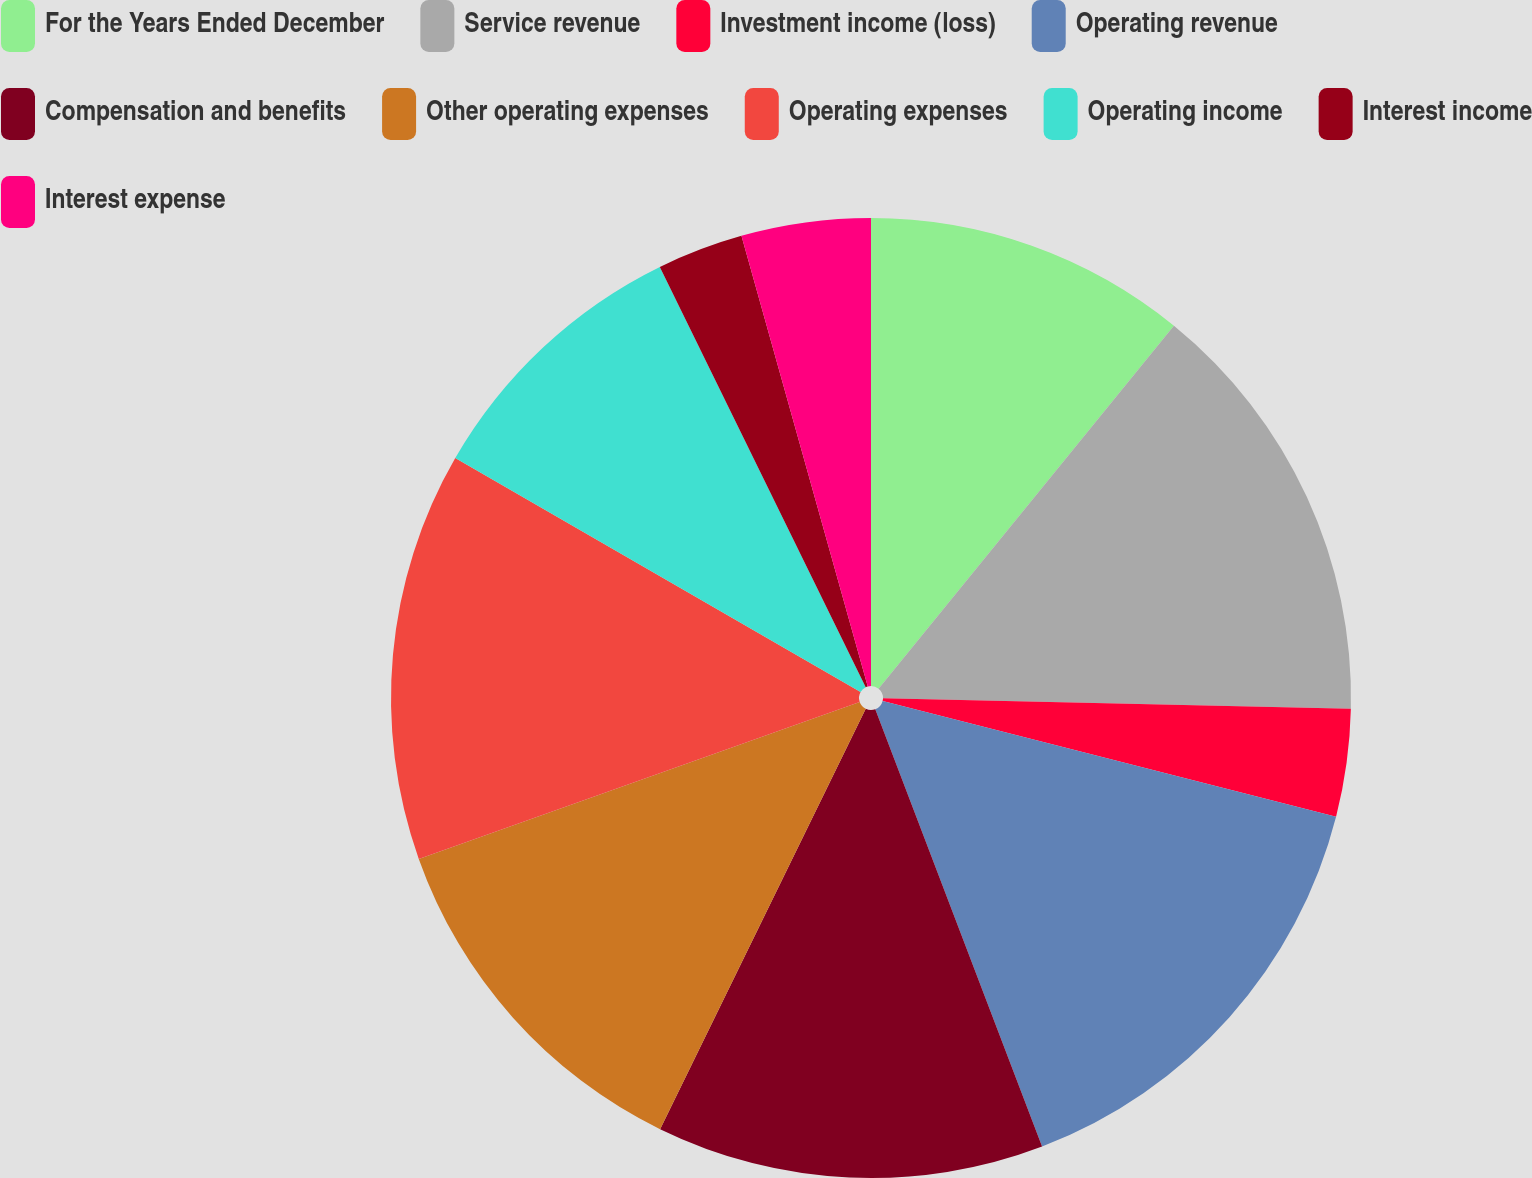Convert chart. <chart><loc_0><loc_0><loc_500><loc_500><pie_chart><fcel>For the Years Ended December<fcel>Service revenue<fcel>Investment income (loss)<fcel>Operating revenue<fcel>Compensation and benefits<fcel>Other operating expenses<fcel>Operating expenses<fcel>Operating income<fcel>Interest income<fcel>Interest expense<nl><fcel>10.87%<fcel>14.49%<fcel>3.62%<fcel>15.22%<fcel>13.04%<fcel>12.32%<fcel>13.77%<fcel>9.42%<fcel>2.9%<fcel>4.35%<nl></chart> 